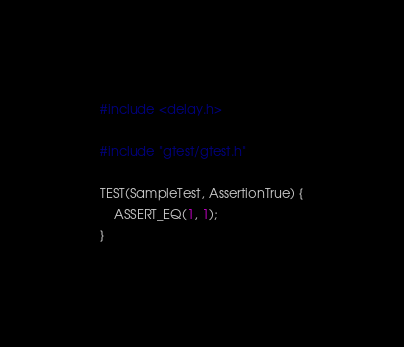Convert code to text. <code><loc_0><loc_0><loc_500><loc_500><_C++_>#include <delay.h>

#include "gtest/gtest.h"

TEST(SampleTest, AssertionTrue) {
    ASSERT_EQ(1, 1);
}
</code> 